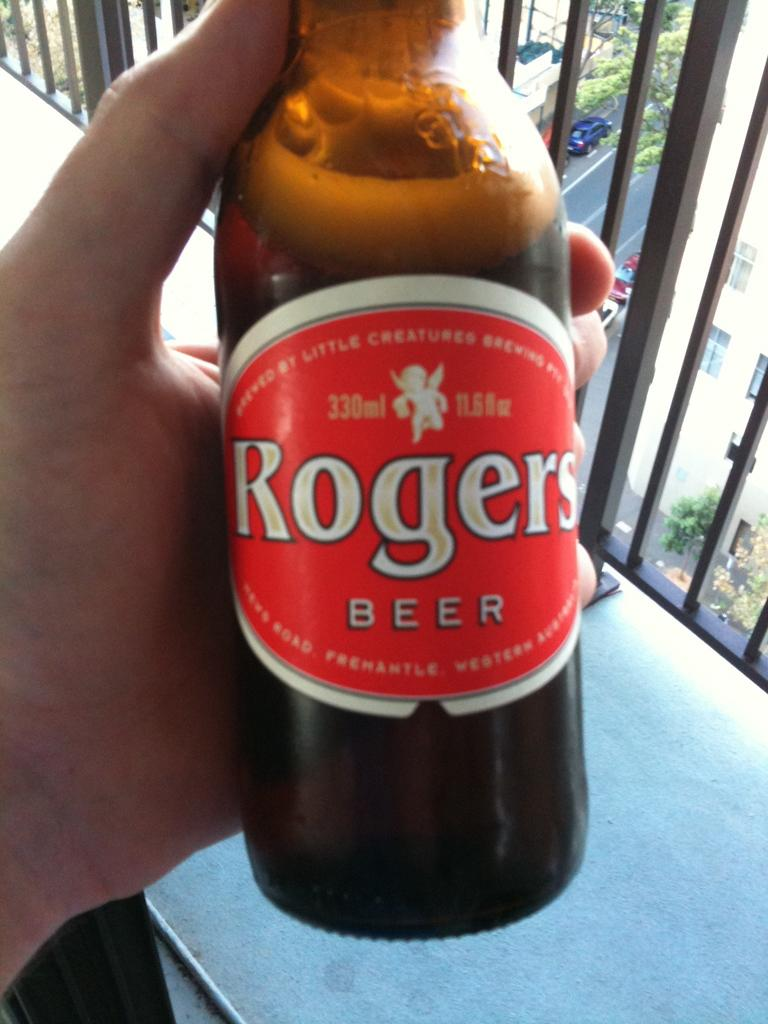<image>
Summarize the visual content of the image. a person is holding a bottle of Rogers beer 